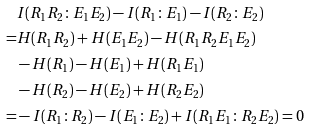Convert formula to latex. <formula><loc_0><loc_0><loc_500><loc_500>& I ( R _ { 1 } R _ { 2 } \colon E _ { 1 } E _ { 2 } ) - I ( R _ { 1 } \colon E _ { 1 } ) - I ( R _ { 2 } \colon E _ { 2 } ) \\ = & H ( R _ { 1 } R _ { 2 } ) + H ( E _ { 1 } E _ { 2 } ) - H ( R _ { 1 } R _ { 2 } E _ { 1 } E _ { 2 } ) \\ & - H ( R _ { 1 } ) - H ( E _ { 1 } ) + H ( R _ { 1 } E _ { 1 } ) \\ & - H ( R _ { 2 } ) - H ( E _ { 2 } ) + H ( R _ { 2 } E _ { 2 } ) \\ = & - I ( R _ { 1 } \colon R _ { 2 } ) - I ( E _ { 1 } \colon E _ { 2 } ) + I ( R _ { 1 } E _ { 1 } \colon R _ { 2 } E _ { 2 } ) = 0</formula> 